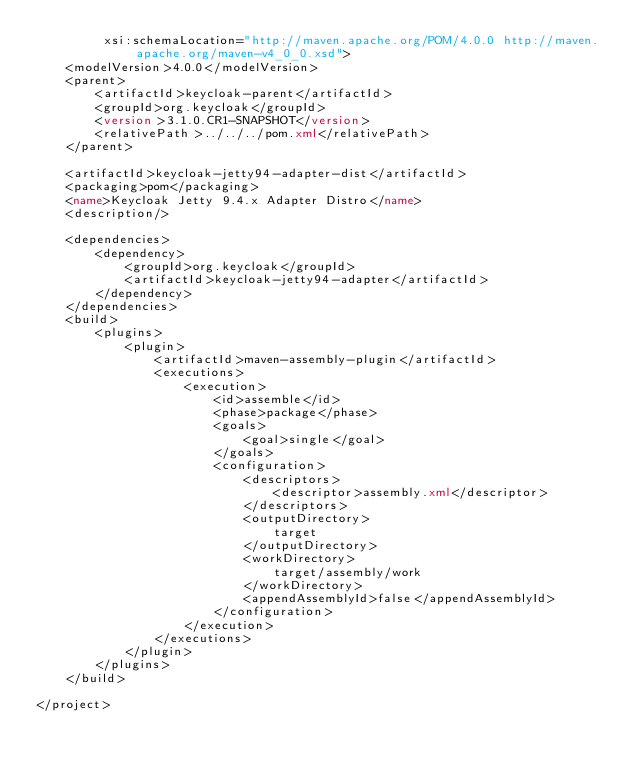Convert code to text. <code><loc_0><loc_0><loc_500><loc_500><_XML_>         xsi:schemaLocation="http://maven.apache.org/POM/4.0.0 http://maven.apache.org/maven-v4_0_0.xsd">
    <modelVersion>4.0.0</modelVersion>
    <parent>
        <artifactId>keycloak-parent</artifactId>
        <groupId>org.keycloak</groupId>
        <version>3.1.0.CR1-SNAPSHOT</version>
        <relativePath>../../../pom.xml</relativePath>
    </parent>

    <artifactId>keycloak-jetty94-adapter-dist</artifactId>
    <packaging>pom</packaging>
    <name>Keycloak Jetty 9.4.x Adapter Distro</name>
    <description/>

    <dependencies>
        <dependency>
            <groupId>org.keycloak</groupId>
            <artifactId>keycloak-jetty94-adapter</artifactId>
        </dependency>
    </dependencies>
    <build>
        <plugins>
            <plugin>
                <artifactId>maven-assembly-plugin</artifactId>
                <executions>
                    <execution>
                        <id>assemble</id>
                        <phase>package</phase>
                        <goals>
                            <goal>single</goal>
                        </goals>
                        <configuration>
                            <descriptors>
                                <descriptor>assembly.xml</descriptor>
                            </descriptors>
                            <outputDirectory>
                                target
                            </outputDirectory>
                            <workDirectory>
                                target/assembly/work
                            </workDirectory>
                            <appendAssemblyId>false</appendAssemblyId>
                        </configuration>
                    </execution>
                </executions>
            </plugin>
        </plugins>
    </build>

</project>
</code> 